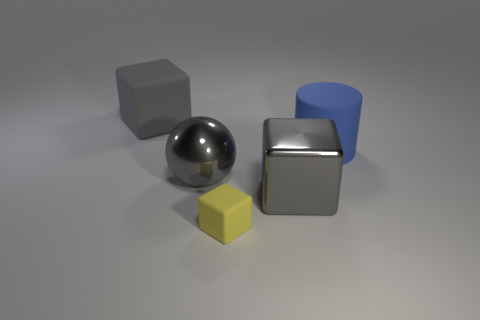Subtract all large gray metal blocks. How many blocks are left? 2 Add 3 large gray metal things. How many objects exist? 8 Subtract all balls. How many objects are left? 4 Subtract all gray cubes. How many cubes are left? 1 Subtract 1 balls. How many balls are left? 0 Subtract all red blocks. Subtract all purple spheres. How many blocks are left? 3 Subtract all yellow cubes. How many red cylinders are left? 0 Subtract all tiny cylinders. Subtract all yellow matte cubes. How many objects are left? 4 Add 3 gray cubes. How many gray cubes are left? 5 Add 2 purple shiny blocks. How many purple shiny blocks exist? 2 